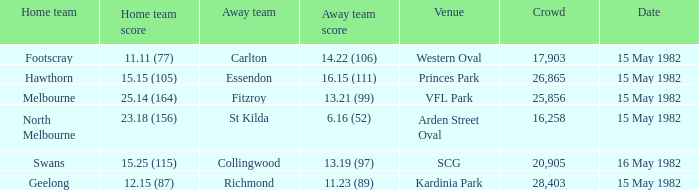Where did Geelong play as the home team? Kardinia Park. 